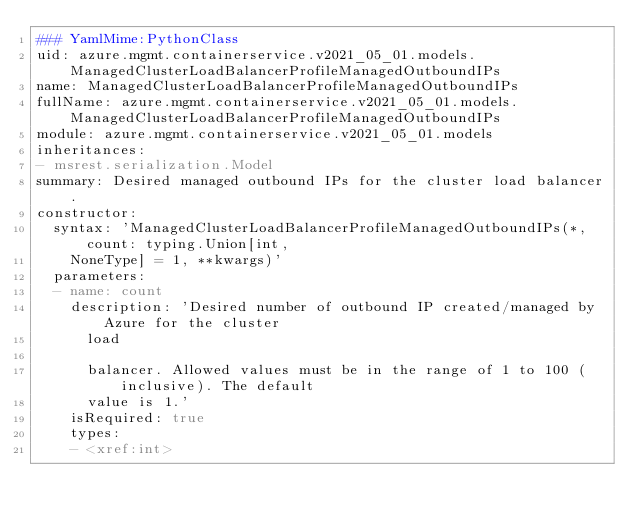Convert code to text. <code><loc_0><loc_0><loc_500><loc_500><_YAML_>### YamlMime:PythonClass
uid: azure.mgmt.containerservice.v2021_05_01.models.ManagedClusterLoadBalancerProfileManagedOutboundIPs
name: ManagedClusterLoadBalancerProfileManagedOutboundIPs
fullName: azure.mgmt.containerservice.v2021_05_01.models.ManagedClusterLoadBalancerProfileManagedOutboundIPs
module: azure.mgmt.containerservice.v2021_05_01.models
inheritances:
- msrest.serialization.Model
summary: Desired managed outbound IPs for the cluster load balancer.
constructor:
  syntax: 'ManagedClusterLoadBalancerProfileManagedOutboundIPs(*, count: typing.Union[int,
    NoneType] = 1, **kwargs)'
  parameters:
  - name: count
    description: 'Desired number of outbound IP created/managed by Azure for the cluster
      load

      balancer. Allowed values must be in the range of 1 to 100 (inclusive). The default
      value is 1.'
    isRequired: true
    types:
    - <xref:int>
</code> 